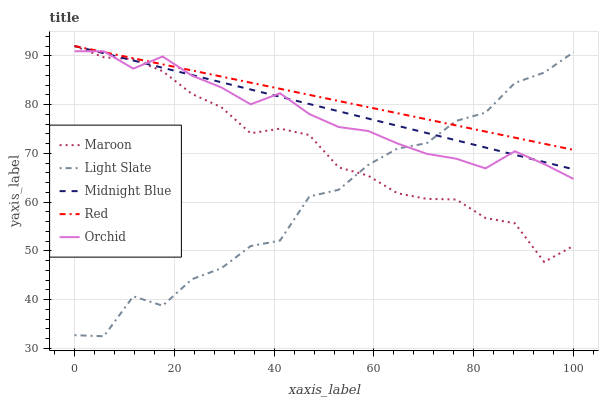Does Light Slate have the minimum area under the curve?
Answer yes or no. Yes. Does Red have the maximum area under the curve?
Answer yes or no. Yes. Does Midnight Blue have the minimum area under the curve?
Answer yes or no. No. Does Midnight Blue have the maximum area under the curve?
Answer yes or no. No. Is Red the smoothest?
Answer yes or no. Yes. Is Light Slate the roughest?
Answer yes or no. Yes. Is Midnight Blue the smoothest?
Answer yes or no. No. Is Midnight Blue the roughest?
Answer yes or no. No. Does Light Slate have the lowest value?
Answer yes or no. Yes. Does Midnight Blue have the lowest value?
Answer yes or no. No. Does Maroon have the highest value?
Answer yes or no. Yes. Does Orchid have the highest value?
Answer yes or no. No. Does Maroon intersect Red?
Answer yes or no. Yes. Is Maroon less than Red?
Answer yes or no. No. Is Maroon greater than Red?
Answer yes or no. No. 